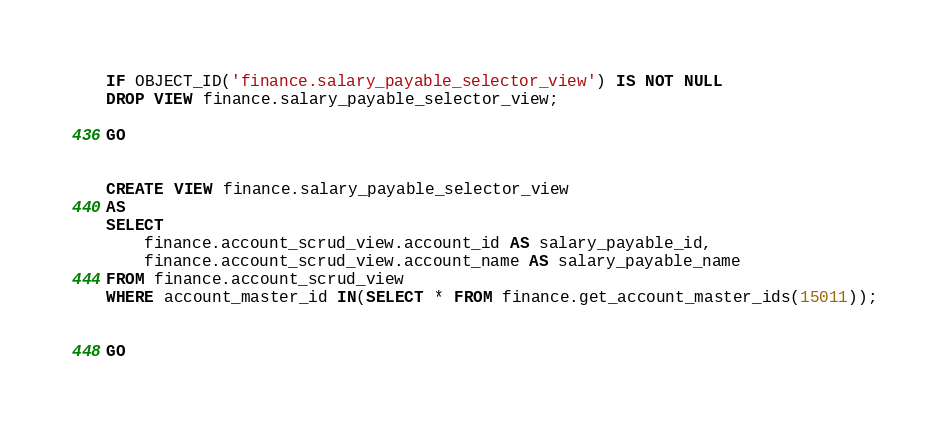Convert code to text. <code><loc_0><loc_0><loc_500><loc_500><_SQL_>IF OBJECT_ID('finance.salary_payable_selector_view') IS NOT NULL
DROP VIEW finance.salary_payable_selector_view;

GO


CREATE VIEW finance.salary_payable_selector_view
AS
SELECT 
    finance.account_scrud_view.account_id AS salary_payable_id,
    finance.account_scrud_view.account_name AS salary_payable_name
FROM finance.account_scrud_view
WHERE account_master_id IN(SELECT * FROM finance.get_account_master_ids(15011));


GO
</code> 